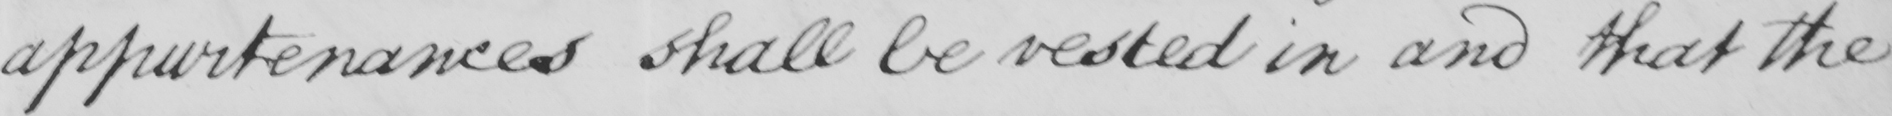What does this handwritten line say? appurtenances shall be vested in and that the 